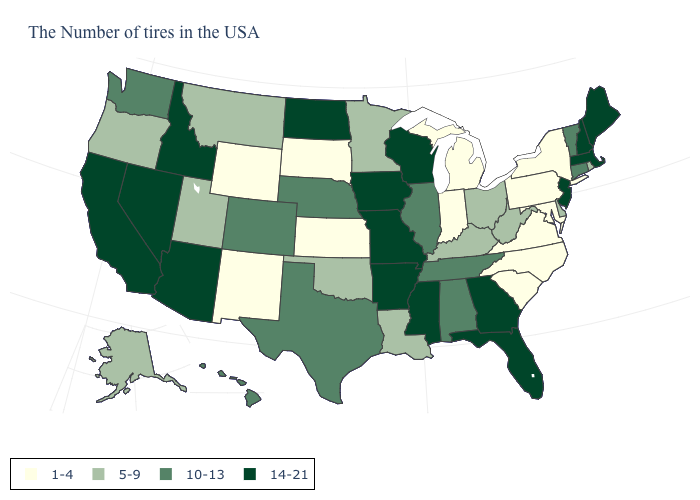Among the states that border South Carolina , does North Carolina have the highest value?
Write a very short answer. No. What is the value of New York?
Be succinct. 1-4. Name the states that have a value in the range 5-9?
Concise answer only. Rhode Island, Delaware, West Virginia, Ohio, Kentucky, Louisiana, Minnesota, Oklahoma, Utah, Montana, Oregon, Alaska. Does the first symbol in the legend represent the smallest category?
Keep it brief. Yes. Does New Jersey have the highest value in the Northeast?
Give a very brief answer. Yes. Name the states that have a value in the range 14-21?
Short answer required. Maine, Massachusetts, New Hampshire, New Jersey, Florida, Georgia, Wisconsin, Mississippi, Missouri, Arkansas, Iowa, North Dakota, Arizona, Idaho, Nevada, California. Name the states that have a value in the range 5-9?
Keep it brief. Rhode Island, Delaware, West Virginia, Ohio, Kentucky, Louisiana, Minnesota, Oklahoma, Utah, Montana, Oregon, Alaska. Does Oregon have a higher value than New York?
Be succinct. Yes. What is the lowest value in the USA?
Short answer required. 1-4. Name the states that have a value in the range 1-4?
Write a very short answer. New York, Maryland, Pennsylvania, Virginia, North Carolina, South Carolina, Michigan, Indiana, Kansas, South Dakota, Wyoming, New Mexico. What is the lowest value in states that border Maine?
Be succinct. 14-21. Name the states that have a value in the range 5-9?
Give a very brief answer. Rhode Island, Delaware, West Virginia, Ohio, Kentucky, Louisiana, Minnesota, Oklahoma, Utah, Montana, Oregon, Alaska. Does the map have missing data?
Be succinct. No. Does the map have missing data?
Quick response, please. No. What is the lowest value in states that border Louisiana?
Give a very brief answer. 10-13. 